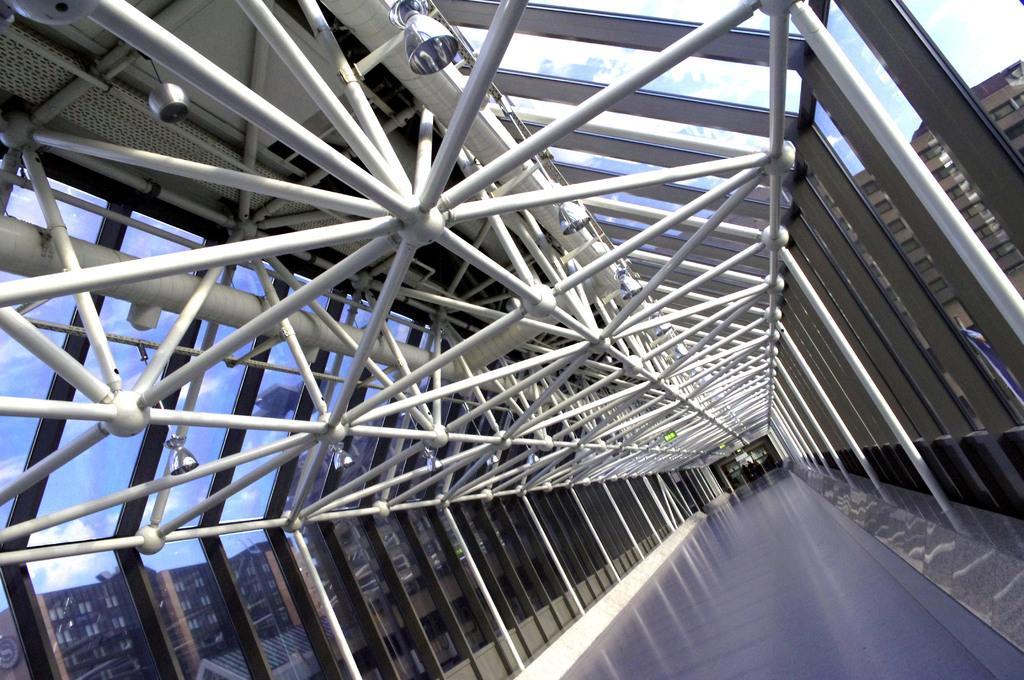Describe this image in one or two sentences. This picture is clicked outside. At the top we can see the metal rods and the lamps hanging on the roof. In the foreground we can see the buildings and the floor. In the background there is a sky and the buildings. 